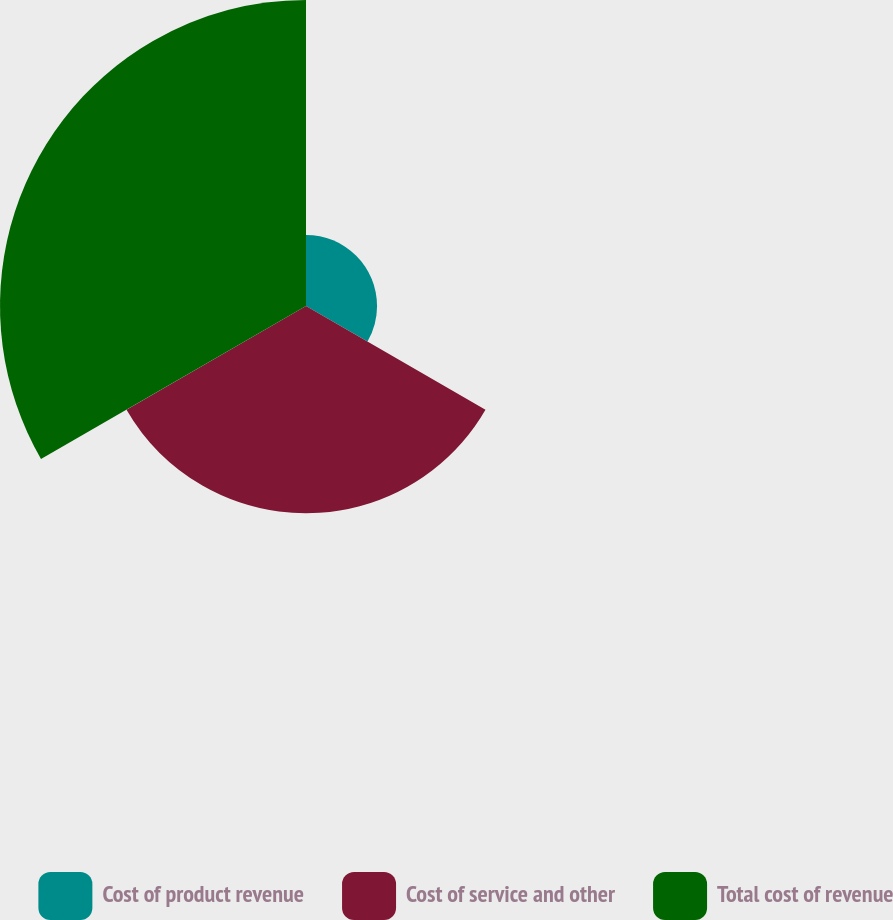Convert chart to OTSL. <chart><loc_0><loc_0><loc_500><loc_500><pie_chart><fcel>Cost of product revenue<fcel>Cost of service and other<fcel>Total cost of revenue<nl><fcel>12.16%<fcel>35.47%<fcel>52.37%<nl></chart> 